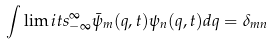<formula> <loc_0><loc_0><loc_500><loc_500>\int \lim i t s _ { - \infty } ^ { \infty } \bar { \psi } _ { m } ( q , t ) \psi _ { n } ( q , t ) d q = \delta _ { m n }</formula> 